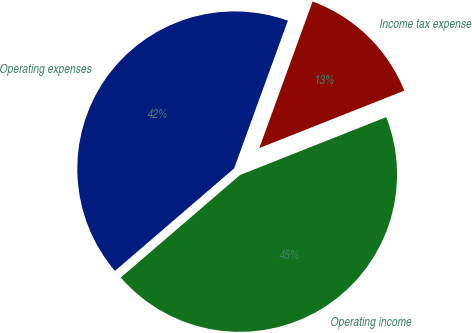Convert chart. <chart><loc_0><loc_0><loc_500><loc_500><pie_chart><fcel>Operating expenses<fcel>Operating income<fcel>Income tax expense<nl><fcel>41.85%<fcel>44.69%<fcel>13.45%<nl></chart> 